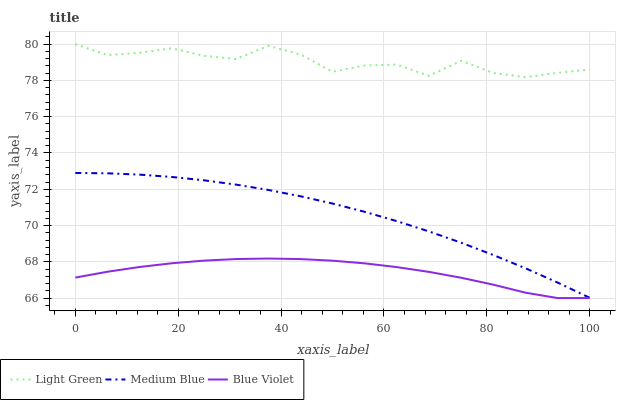Does Blue Violet have the minimum area under the curve?
Answer yes or no. Yes. Does Light Green have the maximum area under the curve?
Answer yes or no. Yes. Does Light Green have the minimum area under the curve?
Answer yes or no. No. Does Blue Violet have the maximum area under the curve?
Answer yes or no. No. Is Medium Blue the smoothest?
Answer yes or no. Yes. Is Light Green the roughest?
Answer yes or no. Yes. Is Blue Violet the smoothest?
Answer yes or no. No. Is Blue Violet the roughest?
Answer yes or no. No. Does Blue Violet have the lowest value?
Answer yes or no. Yes. Does Light Green have the lowest value?
Answer yes or no. No. Does Light Green have the highest value?
Answer yes or no. Yes. Does Blue Violet have the highest value?
Answer yes or no. No. Is Blue Violet less than Light Green?
Answer yes or no. Yes. Is Light Green greater than Medium Blue?
Answer yes or no. Yes. Does Blue Violet intersect Light Green?
Answer yes or no. No. 